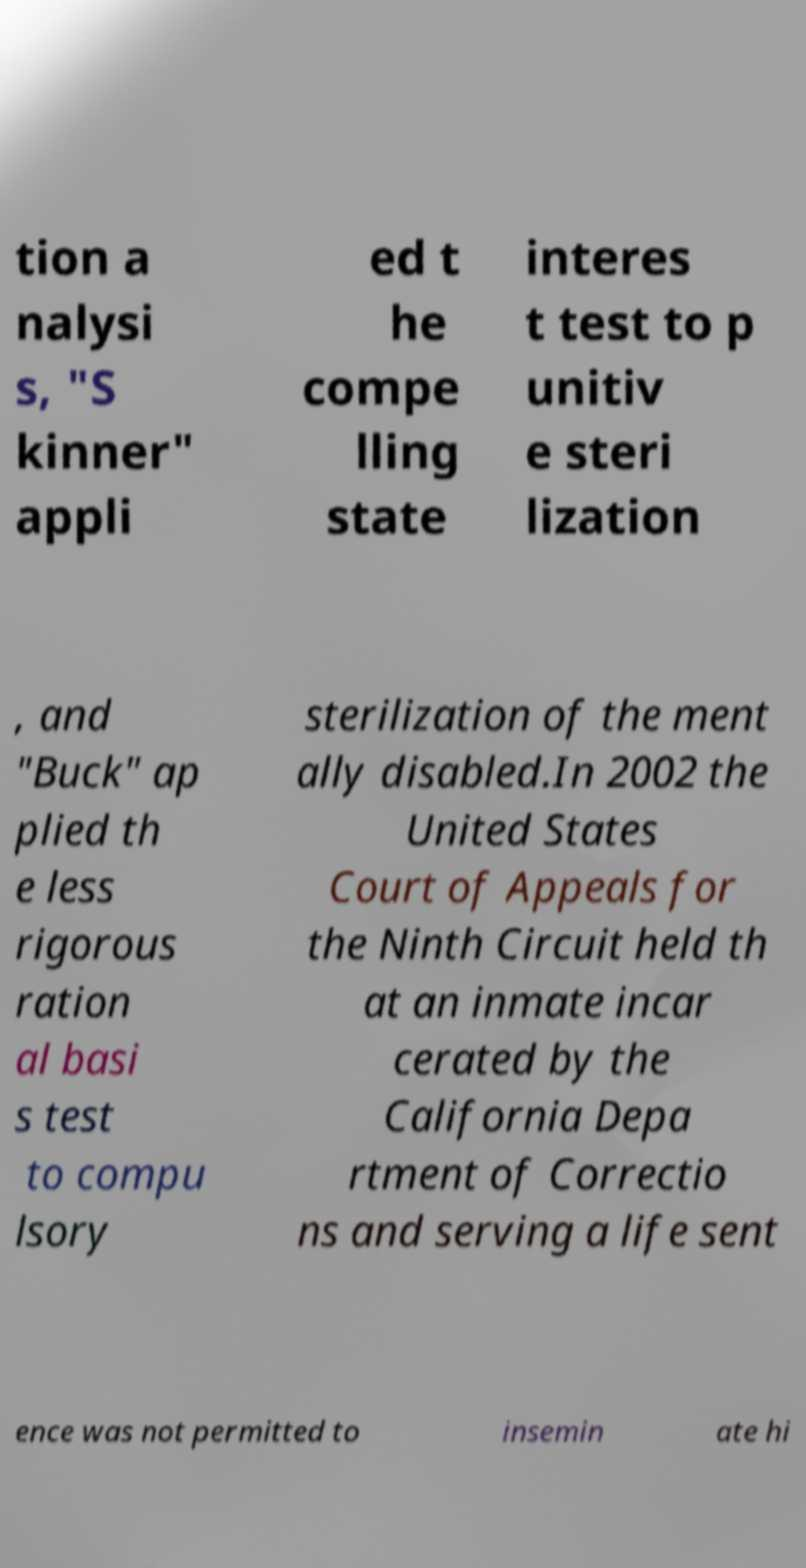I need the written content from this picture converted into text. Can you do that? tion a nalysi s, "S kinner" appli ed t he compe lling state interes t test to p unitiv e steri lization , and "Buck" ap plied th e less rigorous ration al basi s test to compu lsory sterilization of the ment ally disabled.In 2002 the United States Court of Appeals for the Ninth Circuit held th at an inmate incar cerated by the California Depa rtment of Correctio ns and serving a life sent ence was not permitted to insemin ate hi 